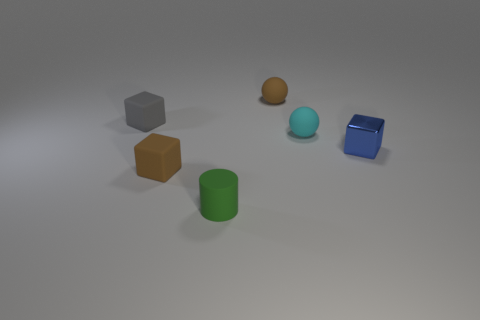Is the number of tiny brown things behind the tiny blue shiny thing less than the number of cubes on the right side of the gray cube?
Offer a very short reply. Yes. What color is the small block that is both in front of the cyan object and on the left side of the blue metallic cube?
Ensure brevity in your answer.  Brown. There is a shiny cube; is its size the same as the brown matte object that is on the left side of the green object?
Your response must be concise. Yes. There is a tiny brown rubber thing that is behind the cyan thing; what is its shape?
Your answer should be very brief. Sphere. Is there any other thing that has the same material as the blue block?
Make the answer very short. No. Are there more rubber blocks that are behind the blue thing than tiny green matte things?
Ensure brevity in your answer.  No. How many metal blocks are on the left side of the tiny block that is right of the cube that is in front of the small blue metal cube?
Your answer should be compact. 0. There is a small sphere that is on the left side of the sphere that is right of the brown sphere; what is its material?
Ensure brevity in your answer.  Rubber. How many objects are either brown things that are behind the small blue block or rubber blocks?
Your answer should be very brief. 3. Are there the same number of matte balls that are to the left of the tiny rubber cylinder and gray matte objects in front of the cyan matte thing?
Make the answer very short. Yes. 